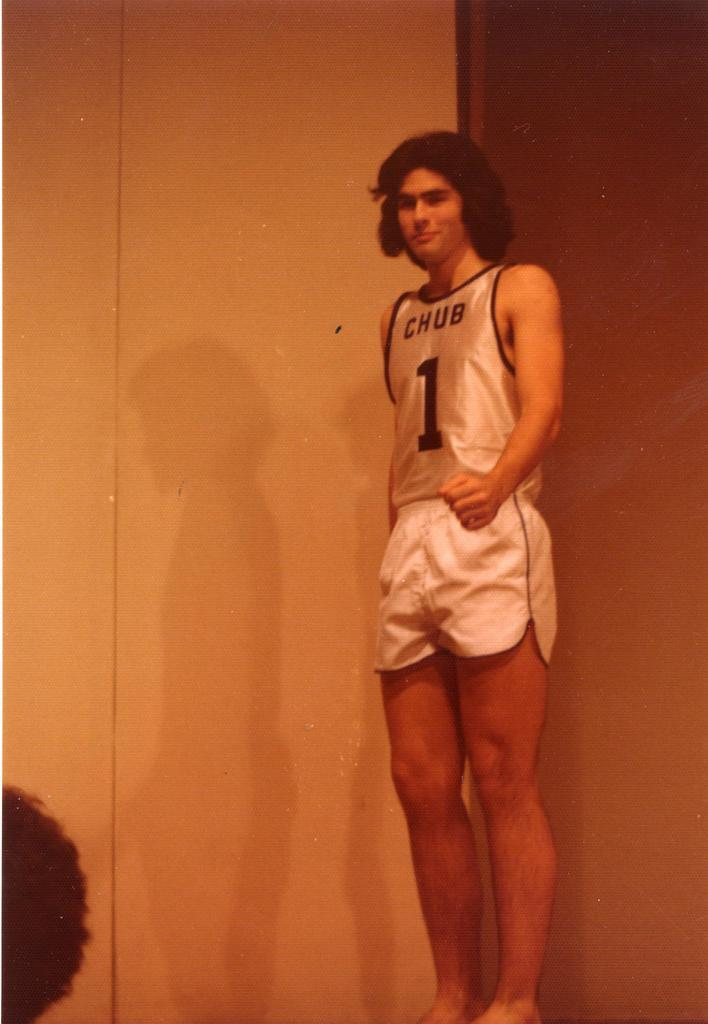What is the main subject of the image? There is a person standing in the middle of the image. What is the person doing in the image? The person is smiling. What can be seen behind the person in the image? There is a wall behind the person. What word is the person saying in the image? There is no indication in the image of what the person might be saying, so it cannot be determined from the picture. 